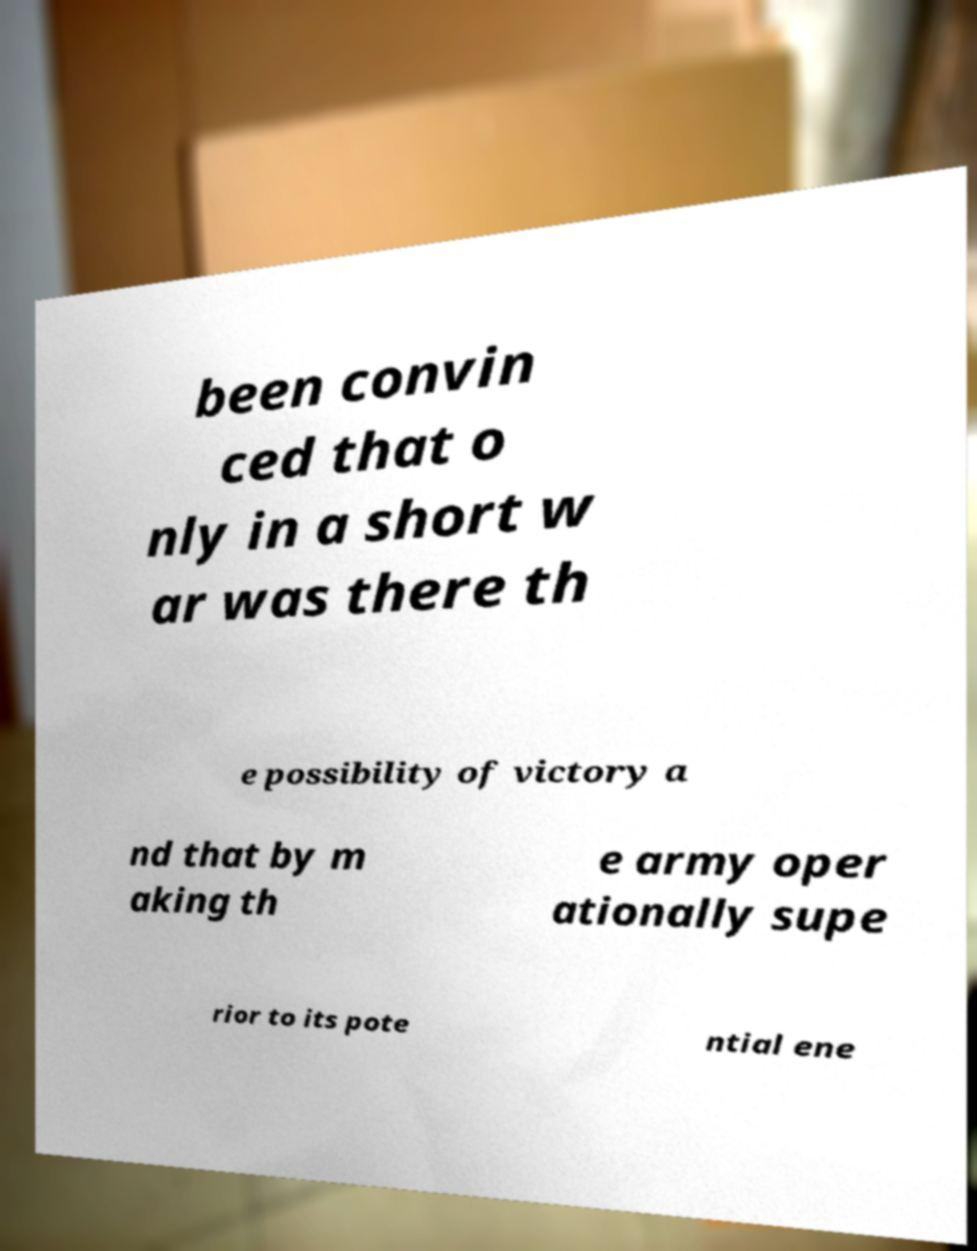For documentation purposes, I need the text within this image transcribed. Could you provide that? been convin ced that o nly in a short w ar was there th e possibility of victory a nd that by m aking th e army oper ationally supe rior to its pote ntial ene 